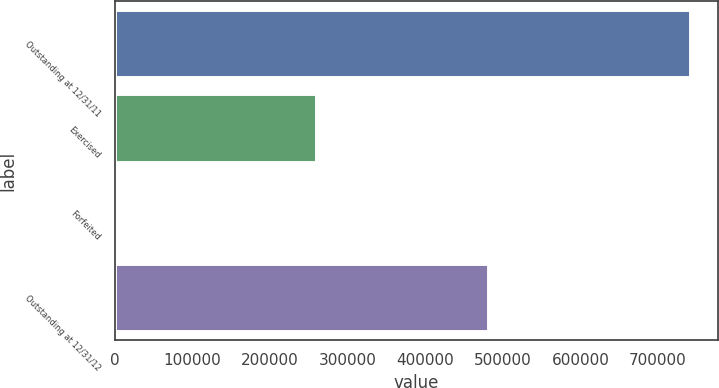Convert chart to OTSL. <chart><loc_0><loc_0><loc_500><loc_500><bar_chart><fcel>Outstanding at 12/31/11<fcel>Exercised<fcel>Forfeited<fcel>Outstanding at 12/31/12<nl><fcel>740875<fcel>258700<fcel>1000<fcel>481175<nl></chart> 